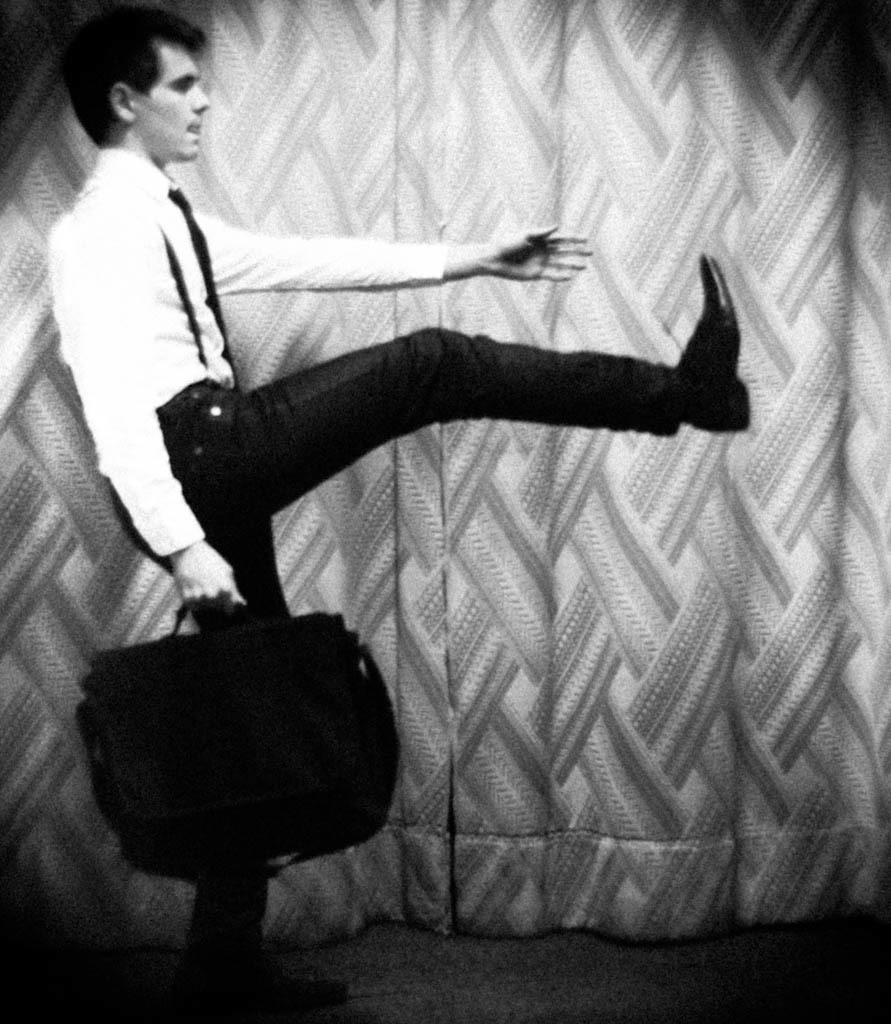Could you give a brief overview of what you see in this image? In this image I can see the person standing and holding the bag. The person is wearing the shirt, pant and also the tie. He is standing to the side of the curtain. And this is a black and white image. 